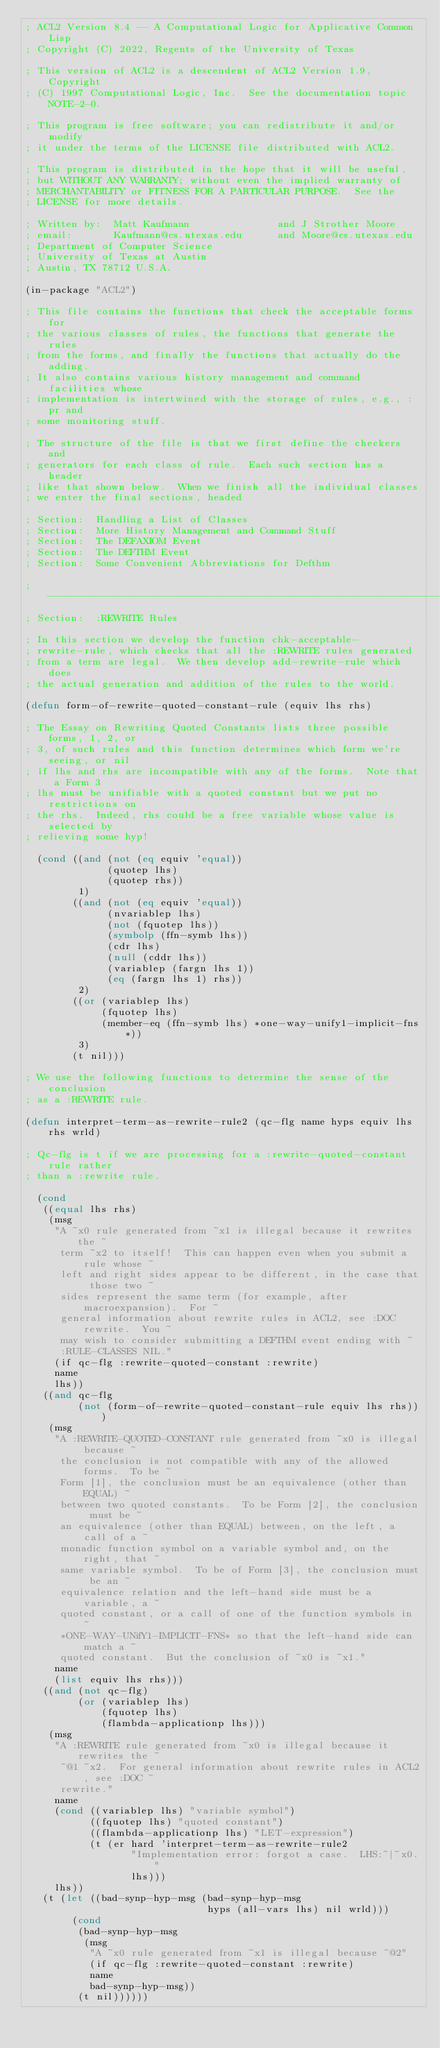Convert code to text. <code><loc_0><loc_0><loc_500><loc_500><_Lisp_>; ACL2 Version 8.4 -- A Computational Logic for Applicative Common Lisp
; Copyright (C) 2022, Regents of the University of Texas

; This version of ACL2 is a descendent of ACL2 Version 1.9, Copyright
; (C) 1997 Computational Logic, Inc.  See the documentation topic NOTE-2-0.

; This program is free software; you can redistribute it and/or modify
; it under the terms of the LICENSE file distributed with ACL2.

; This program is distributed in the hope that it will be useful,
; but WITHOUT ANY WARRANTY; without even the implied warranty of
; MERCHANTABILITY or FITNESS FOR A PARTICULAR PURPOSE.  See the
; LICENSE for more details.

; Written by:  Matt Kaufmann               and J Strother Moore
; email:       Kaufmann@cs.utexas.edu      and Moore@cs.utexas.edu
; Department of Computer Science
; University of Texas at Austin
; Austin, TX 78712 U.S.A.

(in-package "ACL2")

; This file contains the functions that check the acceptable forms for
; the various classes of rules, the functions that generate the rules
; from the forms, and finally the functions that actually do the adding.
; It also contains various history management and command facilities whose
; implementation is intertwined with the storage of rules, e.g., :pr and
; some monitoring stuff.

; The structure of the file is that we first define the checkers and
; generators for each class of rule.  Each such section has a header
; like that shown below.  When we finish all the individual classes
; we enter the final sections, headed

; Section:  Handling a List of Classes
; Section:  More History Management and Command Stuff
; Section:  The DEFAXIOM Event
; Section:  The DEFTHM Event
; Section:  Some Convenient Abbreviations for Defthm

;---------------------------------------------------------------------------
; Section:  :REWRITE Rules

; In this section we develop the function chk-acceptable-
; rewrite-rule, which checks that all the :REWRITE rules generated
; from a term are legal.  We then develop add-rewrite-rule which does
; the actual generation and addition of the rules to the world.

(defun form-of-rewrite-quoted-constant-rule (equiv lhs rhs)

; The Essay on Rewriting Quoted Constants lists three possible forms, 1, 2, or
; 3, of such rules and this function determines which form we're seeing, or nil
; if lhs and rhs are incompatible with any of the forms.  Note that a Form 3
; lhs must be unifiable with a quoted constant but we put no restrictions on
; the rhs.  Indeed, rhs could be a free variable whose value is selected by
; relieving some hyp!

  (cond ((and (not (eq equiv 'equal))
              (quotep lhs)
              (quotep rhs))
         1)
        ((and (not (eq equiv 'equal))
              (nvariablep lhs)
              (not (fquotep lhs))
              (symbolp (ffn-symb lhs))
              (cdr lhs)
              (null (cddr lhs))
              (variablep (fargn lhs 1))
              (eq (fargn lhs 1) rhs))
         2)
        ((or (variablep lhs)
             (fquotep lhs)
             (member-eq (ffn-symb lhs) *one-way-unify1-implicit-fns*))
         3)
        (t nil)))

; We use the following functions to determine the sense of the conclusion
; as a :REWRITE rule.

(defun interpret-term-as-rewrite-rule2 (qc-flg name hyps equiv lhs rhs wrld)

; Qc-flg is t if we are processing for a :rewrite-quoted-constant rule rather
; than a :rewrite rule.

  (cond
   ((equal lhs rhs)
    (msg
     "A ~x0 rule generated from ~x1 is illegal because it rewrites the ~
      term ~x2 to itself!  This can happen even when you submit a rule whose ~
      left and right sides appear to be different, in the case that those two ~
      sides represent the same term (for example, after macroexpansion).  For ~
      general information about rewrite rules in ACL2, see :DOC rewrite.  You ~
      may wish to consider submitting a DEFTHM event ending with ~
      :RULE-CLASSES NIL."
     (if qc-flg :rewrite-quoted-constant :rewrite)
     name
     lhs))
   ((and qc-flg
         (not (form-of-rewrite-quoted-constant-rule equiv lhs rhs)))
    (msg
     "A :REWRITE-QUOTED-CONSTANT rule generated from ~x0 is illegal because ~
      the conclusion is not compatible with any of the allowed forms.  To be ~
      Form [1], the conclusion must be an equivalence (other than EQUAL) ~
      between two quoted constants.  To be Form [2], the conclusion must be ~
      an equivalence (other than EQUAL) between, on the left, a call of a ~
      monadic function symbol on a variable symbol and, on the right, that ~
      same variable symbol.  To be of Form [3], the conclusion must be an ~
      equivalence relation and the left-hand side must be a variable, a ~
      quoted constant, or a call of one of the function symbols in ~
      *ONE-WAY-UNifY1-IMPLICIT-FNS* so that the left-hand side can match a ~
      quoted constant.  But the conclusion of ~x0 is ~x1."
     name
     (list equiv lhs rhs)))
   ((and (not qc-flg)
         (or (variablep lhs)
             (fquotep lhs)
             (flambda-applicationp lhs)))
    (msg
     "A :REWRITE rule generated from ~x0 is illegal because it rewrites the ~
      ~@1 ~x2.  For general information about rewrite rules in ACL2, see :DOC ~
      rewrite."
     name
     (cond ((variablep lhs) "variable symbol")
           ((fquotep lhs) "quoted constant")
           ((flambda-applicationp lhs) "LET-expression")
           (t (er hard 'interpret-term-as-rewrite-rule2
                  "Implementation error: forgot a case.  LHS:~|~x0."
                  lhs)))
     lhs))
   (t (let ((bad-synp-hyp-msg (bad-synp-hyp-msg
                               hyps (all-vars lhs) nil wrld)))
        (cond
         (bad-synp-hyp-msg
          (msg
           "A ~x0 rule generated from ~x1 is illegal because ~@2"
           (if qc-flg :rewrite-quoted-constant :rewrite)
           name
           bad-synp-hyp-msg))
         (t nil))))))
</code> 